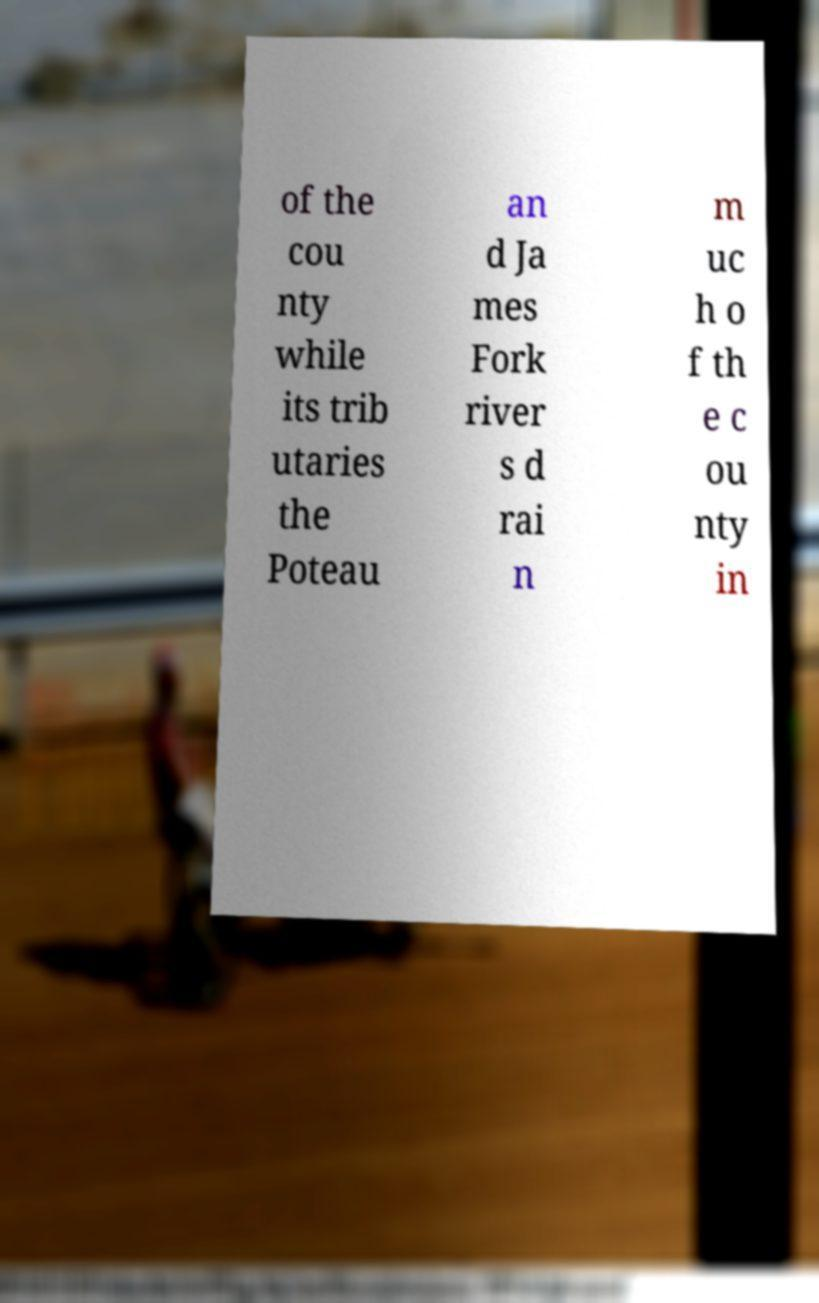Can you accurately transcribe the text from the provided image for me? of the cou nty while its trib utaries the Poteau an d Ja mes Fork river s d rai n m uc h o f th e c ou nty in 